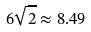Convert formula to latex. <formula><loc_0><loc_0><loc_500><loc_500>6 \sqrt { 2 } \approx 8 . 4 9</formula> 